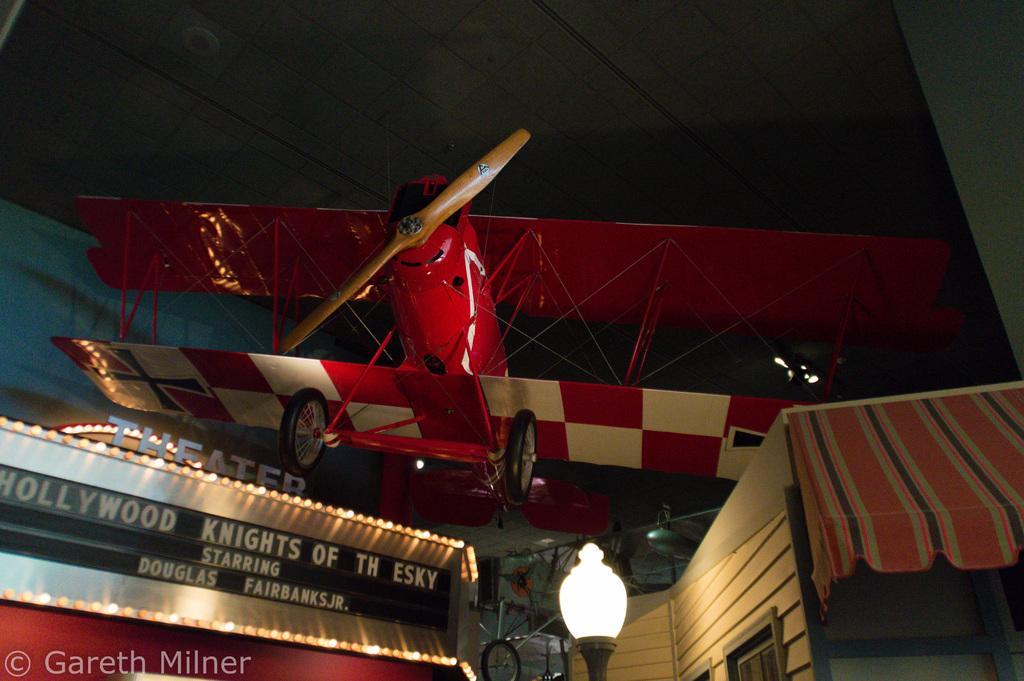Please provide a concise description of this image. In this image there is an airplane in the middle. At the bottom there is a hoarding which is surrounded by the lights. In the middle there is a light. On the right side there is a house. 